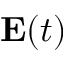<formula> <loc_0><loc_0><loc_500><loc_500>{ E } ( t )</formula> 